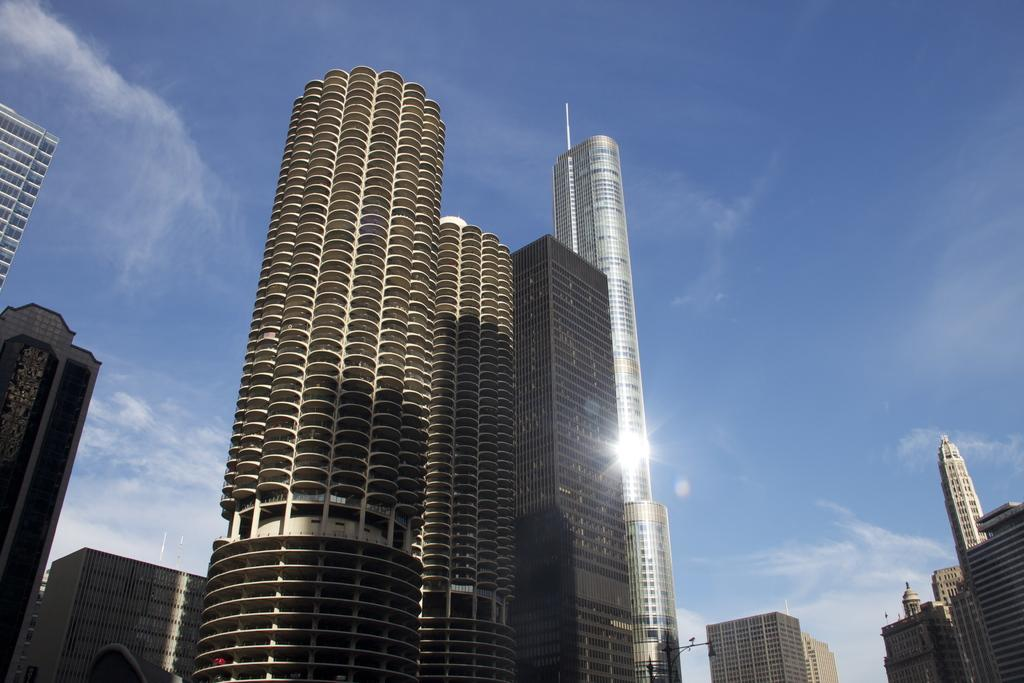What structures are located in the middle of the image? There are buildings in the middle of the image. What is visible at the top of the image? The sky is visible at the top of the image. Where is the can placed in the image? There is no can present in the image. What type of body is visible in the image? There is no body present in the image; it features buildings and the sky. Can you see any goldfish in the image? There are no goldfish present in the image. 